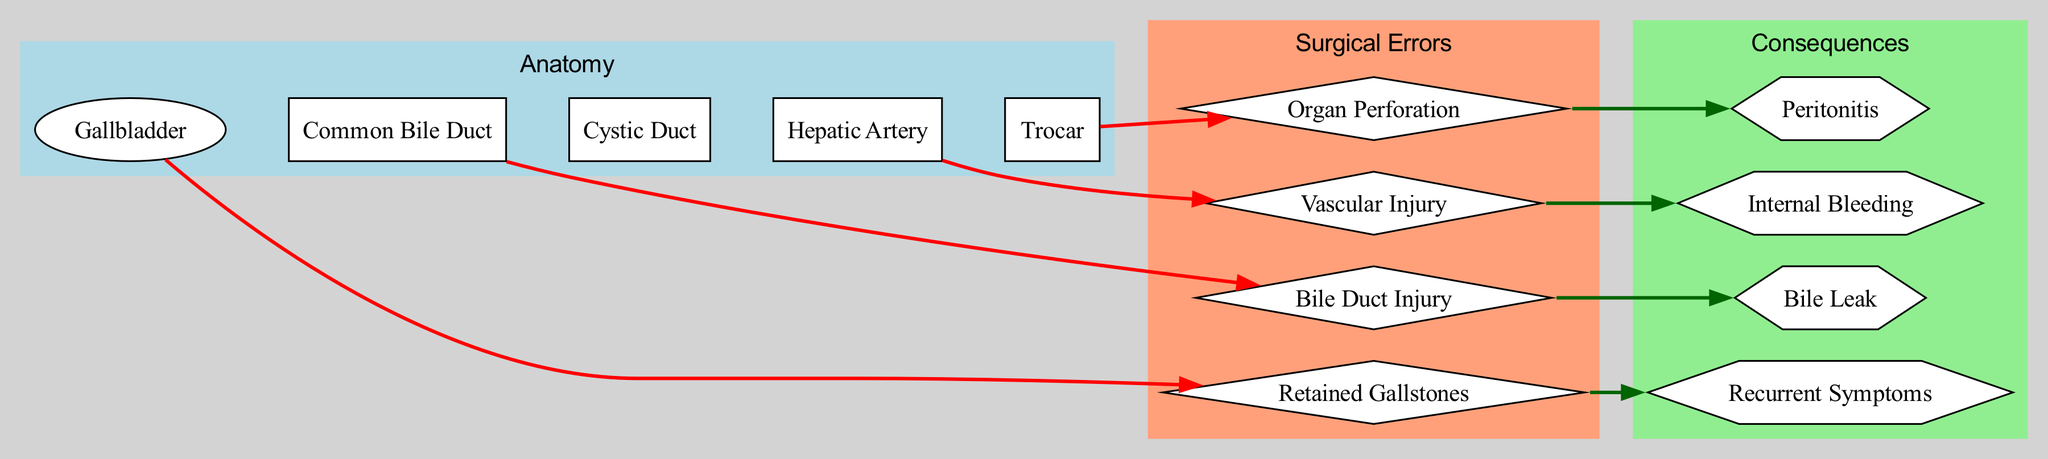What organ is represented in the diagram? The diagram includes several nodes, one of which is labeled "Gallbladder," indicating it represents an organ.
Answer: Gallbladder How many surgical errors are represented in the diagram? Upon examining the errors section of the diagram, there are four distinct surgical errors listed, which can be counted directly.
Answer: 4 What is the surgical error associated with the common bile duct? The diagram shows a connection between the "Common Bile Duct" node and the "Bile Duct Injury" error, which indicates it is specifically associated with this anatomical structure.
Answer: Bile Duct Injury What consequence is linked to organ perforation? By tracing the edge from the "Organ Perforation" error, the diagram shows it leads to "Peritonitis," showing this consequence is directly associated with that error.
Answer: Peritonitis Which surgical instrument is connected to the error of organ perforation? The diagram indicates a link from the "Trocar" node to the "Organ Perforation" error, showing that this surgical instrument is associated with the injury caused.
Answer: Trocar What anatomical structure is involved in the vascular injury error? The "Hepatic Artery" node is linked to the "Vascular Injury" error in the diagram, indicating this anatomical structure is involved in that specific error.
Answer: Hepatic Artery How does the error of retained gallstones relate to its consequence? The "Retained Gallstones" error is connected to "Recurrent Symptoms" in the consequences section of the diagram, showing a direct relationship between the two.
Answer: Recurrent Symptoms Which surgical error causes internal bleeding? Referring to the diagram, the "Vascular Injury" error is identified directly as causing "Internal Bleeding," establishing the connection between them.
Answer: Vascular Injury What color is used for the anatomy subgraph in the diagram? The subgraph for anatomy is labeled with a color attribute "lightblue," which can be seen in the diagram's color coding for subgraphs.
Answer: lightblue What shape represents the surgical errors within the diagram? The errors are displayed in a diamond shape, which is specified in the diagram's structure for representing these particular nodes.
Answer: diamond 